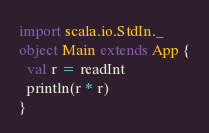Convert code to text. <code><loc_0><loc_0><loc_500><loc_500><_Scala_>import scala.io.StdIn._
object Main extends App {
  val r = readInt
  println(r * r)
}</code> 